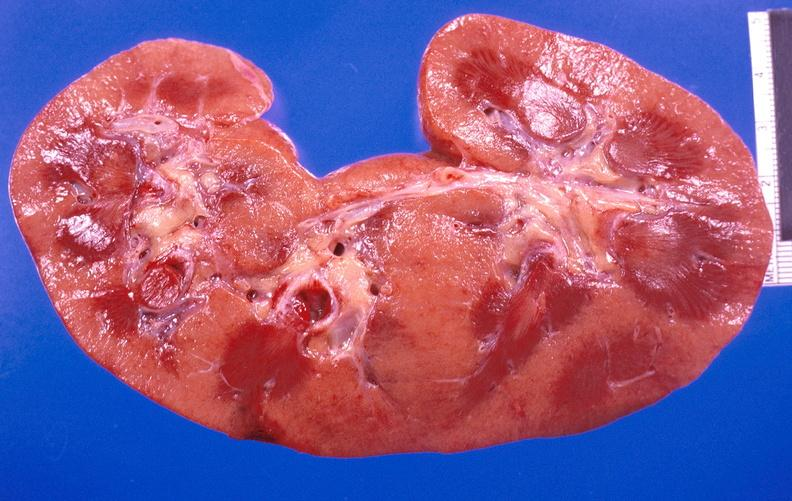does this image show kidney aspergillosis?
Answer the question using a single word or phrase. Yes 